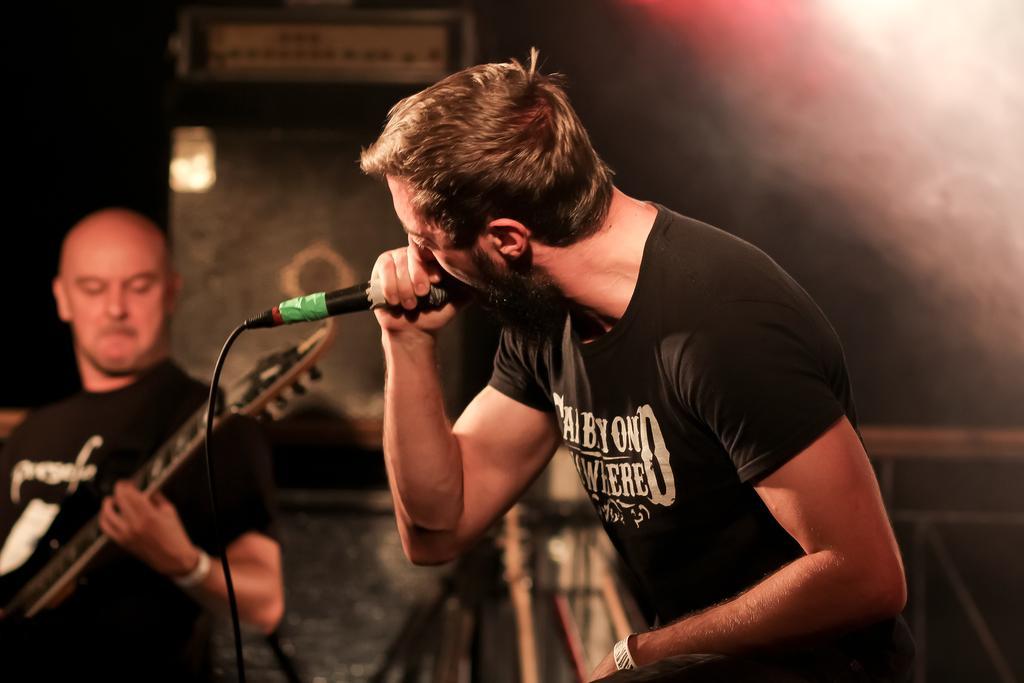In one or two sentences, can you explain what this image depicts? Here in the middle we can see a man singing with a microphone in his hand and beside him we can see a person playing guitar 